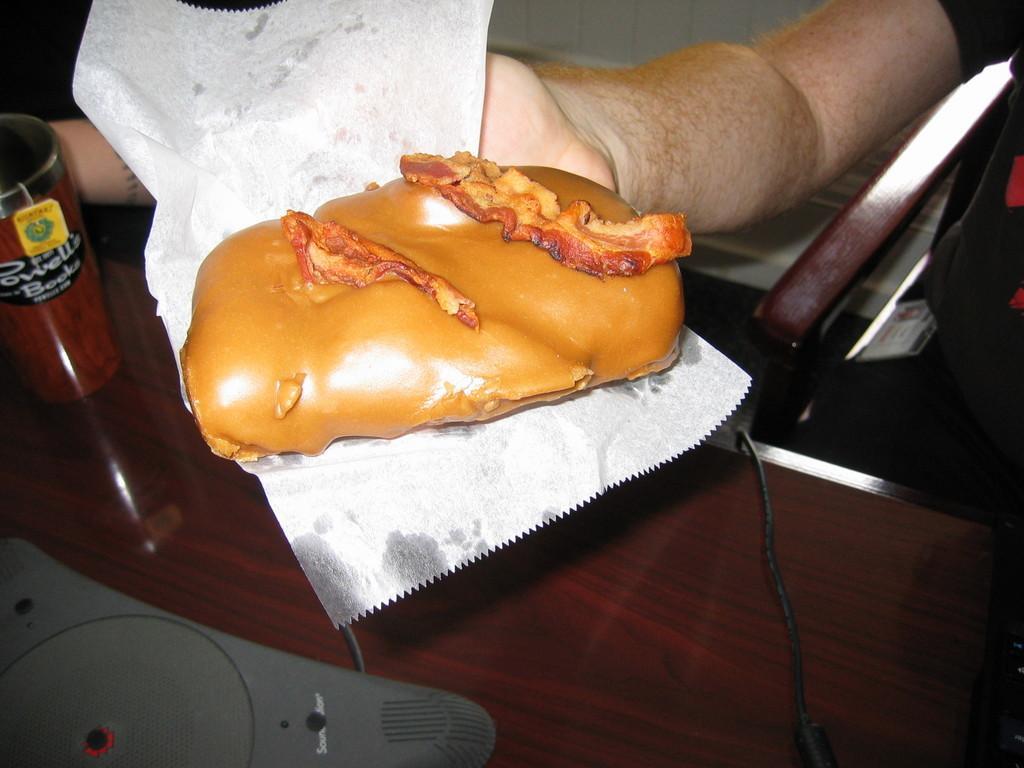How would you summarize this image in a sentence or two? In this image a person is sitting on the chair. He is holding a bread in his hand. Bread is kept on a tissue paper. Left side there is a glass on the table having an object on it. 